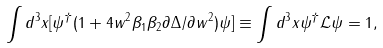<formula> <loc_0><loc_0><loc_500><loc_500>\int d ^ { 3 } x [ \psi ^ { \dag } ( 1 + 4 w ^ { 2 } \beta _ { 1 } \beta _ { 2 } \partial \Delta / \partial w ^ { 2 } ) \psi ] \equiv \int d ^ { 3 } x \psi ^ { \dag } \mathcal { L } \psi = 1 ,</formula> 